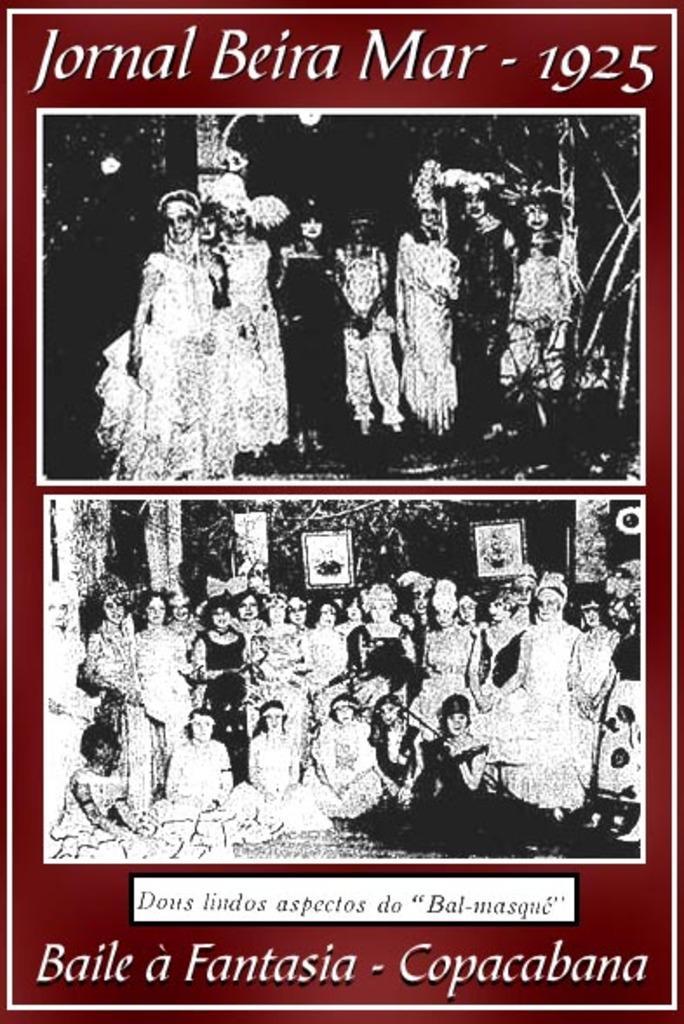Could you give a brief overview of what you see in this image? Here we can see a poster, there are two pictures in this poster, in this picture we can see some people standing and some people sitting, in this picture there are some people standing,on these two pictures are black and white pictures, at the bottom there is some text. 